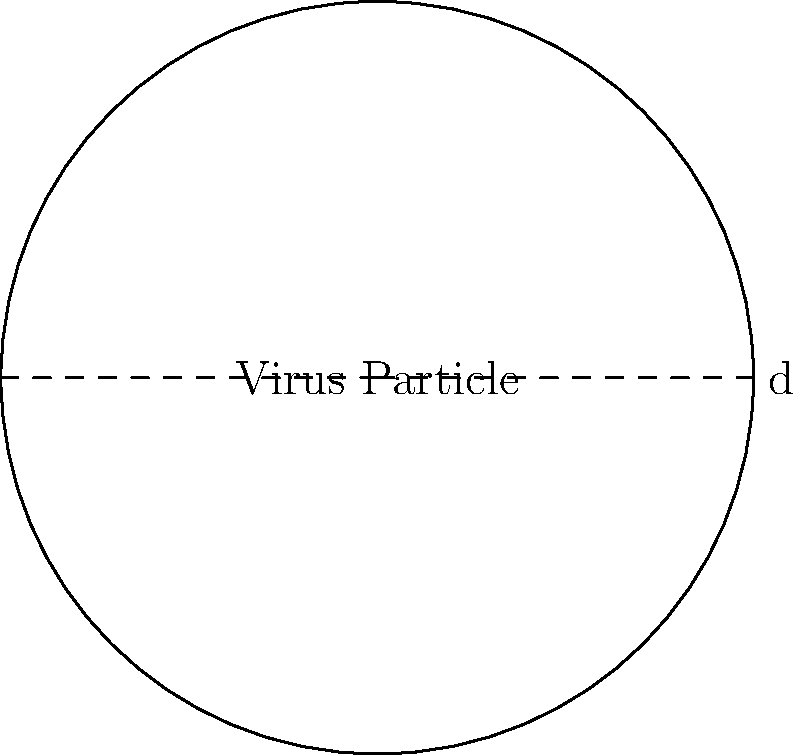A newly discovered spherical virus particle has a diameter of 120 nanometers. As an expert in virology, calculate the surface area of this virus particle. Express your answer in square nanometers (nm²) and round to the nearest whole number. To calculate the surface area of a spherical virus particle, we can use the formula for the surface area of a sphere:

$$A = 4\pi r^2$$

Where:
$A$ is the surface area
$r$ is the radius of the sphere

Given:
- The diameter of the virus particle is 120 nm
- The radius is half the diameter: $r = 120 \div 2 = 60$ nm

Steps:
1. Substitute the radius into the formula:
   $$A = 4\pi (60\text{ nm})^2$$

2. Calculate the square of the radius:
   $$A = 4\pi (3600\text{ nm}^2)$$

3. Multiply by 4π:
   $$A = 45238.93\text{ nm}^2$$

4. Round to the nearest whole number:
   $$A \approx 45239\text{ nm}^2$$

Therefore, the surface area of the virus particle is approximately 45,239 nm².
Answer: 45,239 nm² 